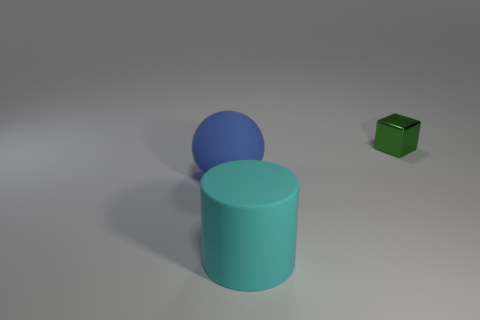Does the large object behind the big cyan cylinder have the same material as the object to the right of the large cyan rubber thing?
Your response must be concise. No. The large thing that is on the right side of the big thing behind the large cyan rubber cylinder is made of what material?
Ensure brevity in your answer.  Rubber. There is a cyan matte cylinder to the right of the big rubber object that is behind the big matte object on the right side of the big blue ball; how big is it?
Make the answer very short. Large. Is the size of the blue ball the same as the green shiny object?
Give a very brief answer. No. There is a thing to the left of the cyan rubber cylinder; is it the same shape as the thing that is on the right side of the cyan object?
Offer a terse response. No. There is a big object on the right side of the large blue rubber object; is there a big cyan matte cylinder in front of it?
Offer a terse response. No. Are any tiny blue metallic cylinders visible?
Give a very brief answer. No. What number of things are the same size as the cylinder?
Give a very brief answer. 1. What number of objects are both to the right of the big rubber cylinder and in front of the tiny green thing?
Your answer should be compact. 0. Do the thing right of the cyan thing and the large blue sphere have the same size?
Provide a short and direct response. No. 